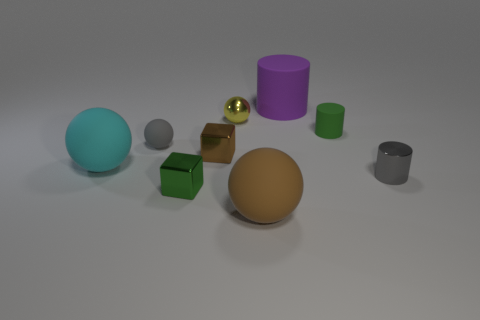What number of large matte objects are the same color as the small metal sphere? There is one large matte object that shares the same golden color as the small metal sphere. 